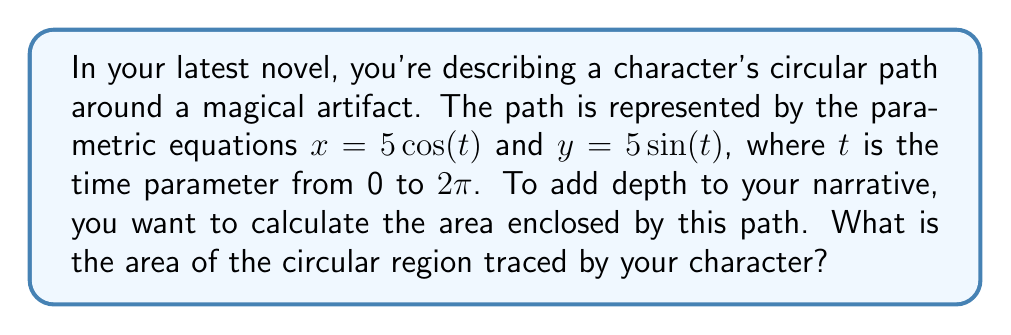Help me with this question. To find the area enclosed by a parametric curve, we can use Green's Theorem, which relates a line integral around a simple closed curve to a double integral over the plane region it encloses. However, since we're dealing with a circular path, we can use a simpler method.

1) First, recognize that the parametric equations $x = 5\cos(t)$ and $y = 5\sin(t)$ describe a circle. This is because:

   $$x^2 + y^2 = (5\cos(t))^2 + (5\sin(t))^2 = 25\cos^2(t) + 25\sin^2(t) = 25(\cos^2(t) + \sin^2(t)) = 25$$

   This is the equation of a circle with radius 5 centered at the origin.

2) The area of a circle is given by the formula $A = \pi r^2$, where $r$ is the radius.

3) In this case, the radius is 5.

4) Therefore, the area is:

   $$A = \pi (5)^2 = 25\pi$$

Thus, the area enclosed by your character's circular path is $25\pi$ square units.
Answer: $25\pi$ square units 